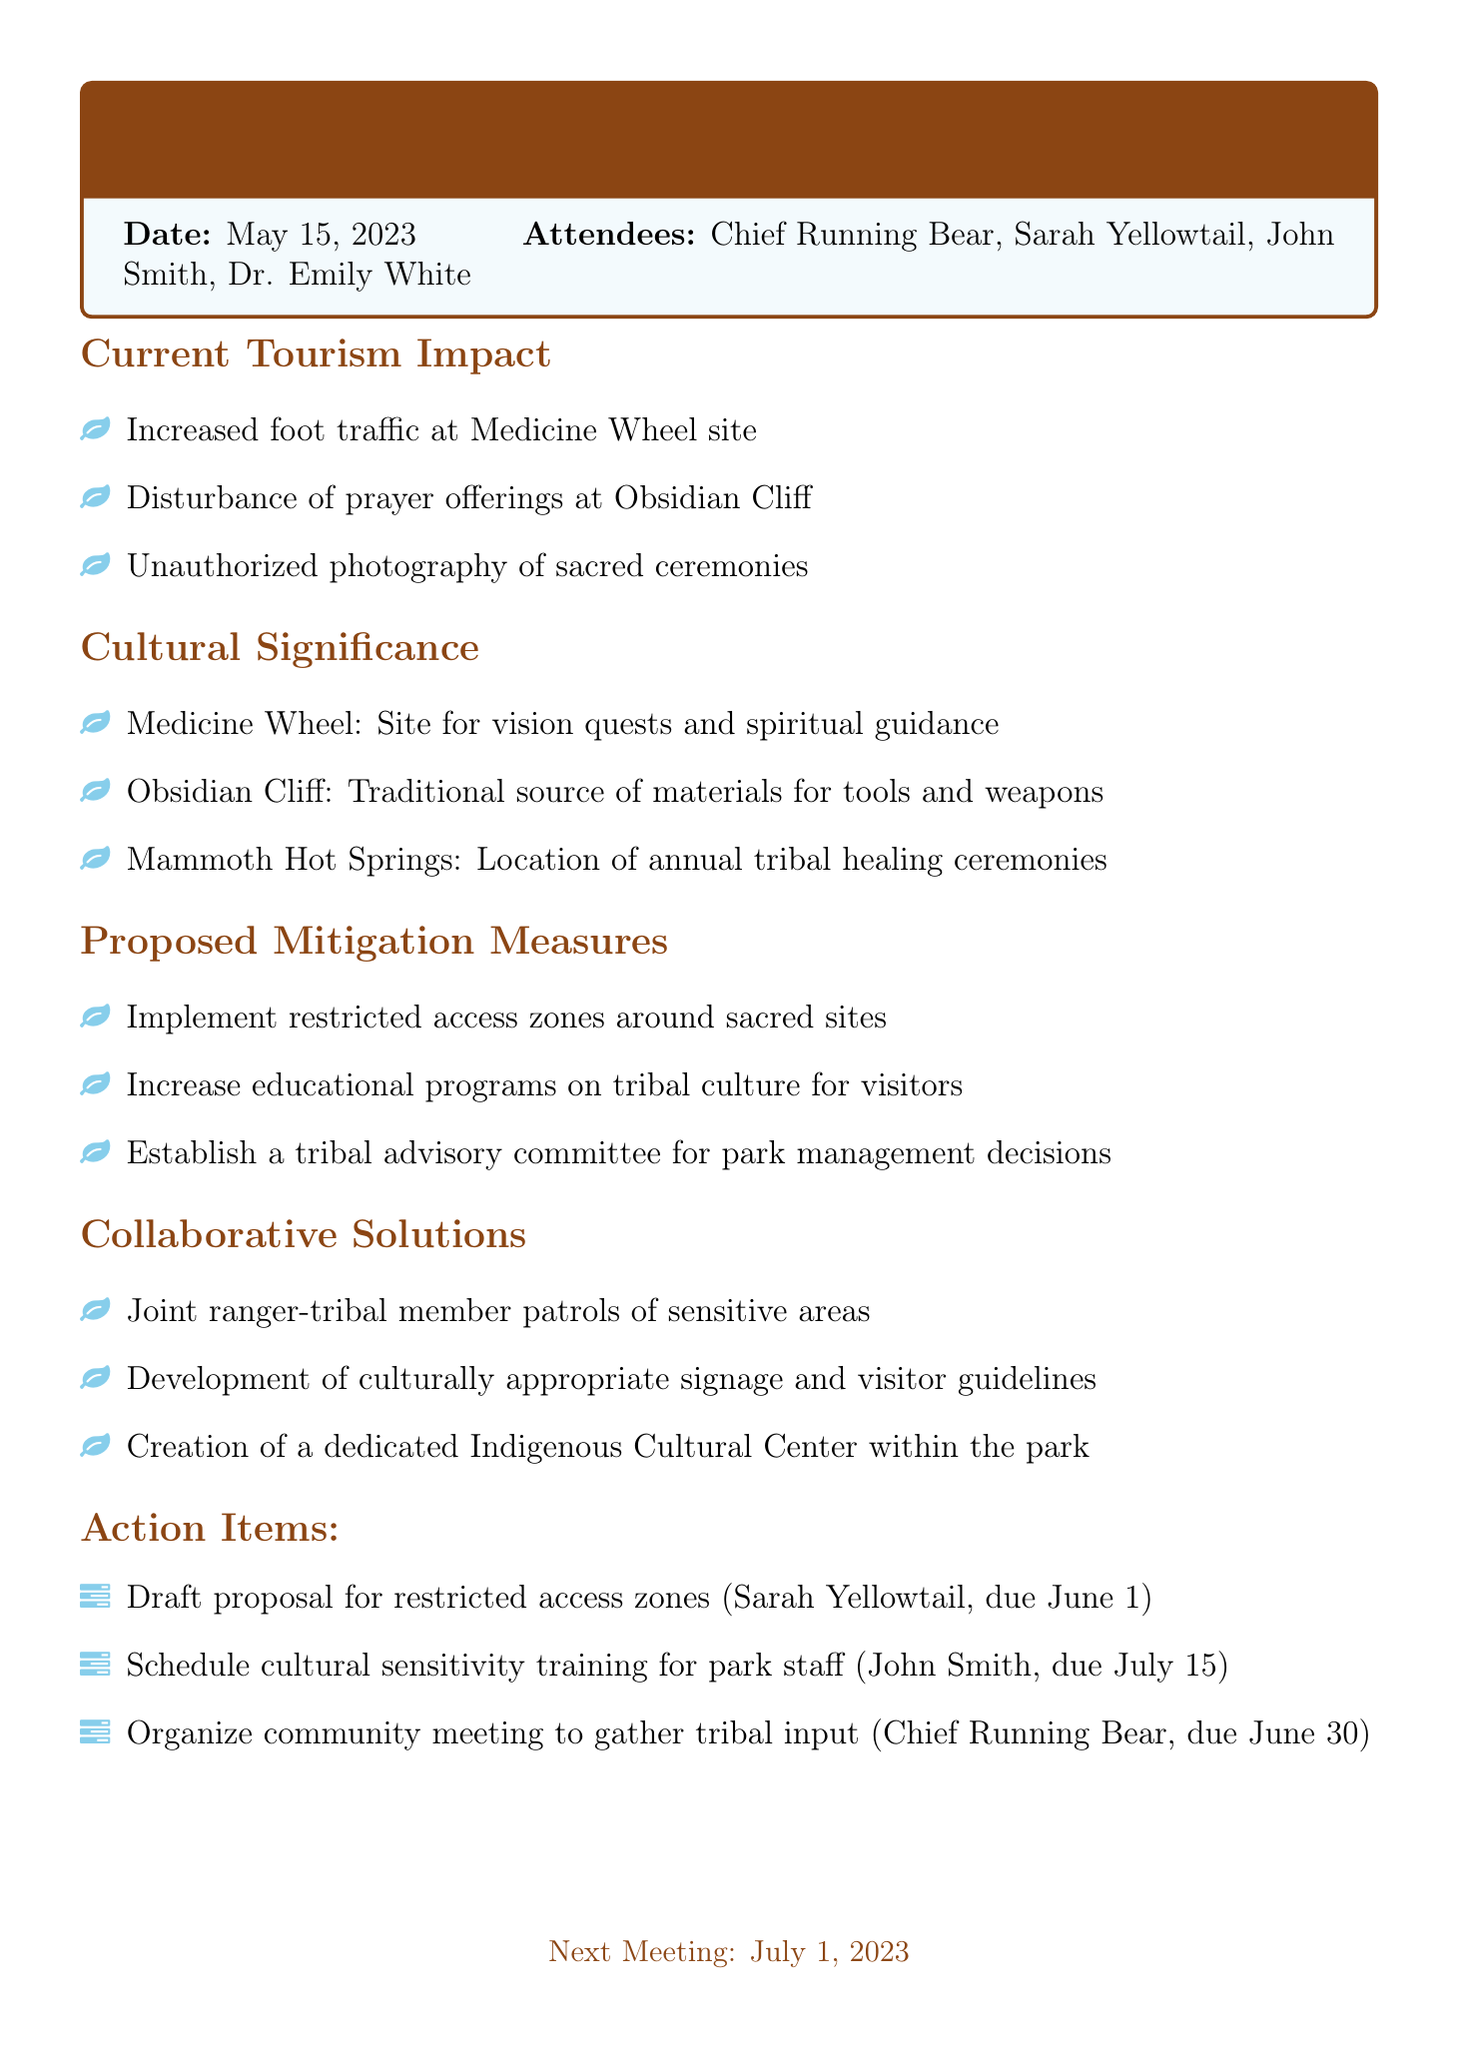what is the meeting title? The meeting title is stated in the document as the main heading.
Answer: Impact of Tourism on Sacred Tribal Sites in Yellowstone National Park who is the park superintendent? The park superintendent is mentioned under the attendees section of the document.
Answer: John Smith what date is the meeting scheduled? The date of the meeting is clearly stated at the beginning of the document.
Answer: May 15, 2023 what are the proposed mitigation measures? The proposed mitigation measures are listed under a separate agenda item in the document.
Answer: Implement restricted access zones around sacred sites, Increase educational programs on tribal culture for visitors, Establish a tribal advisory committee for park management decisions how many attendees were present? The number of attendees can be counted from the list provided in the document.
Answer: Four 